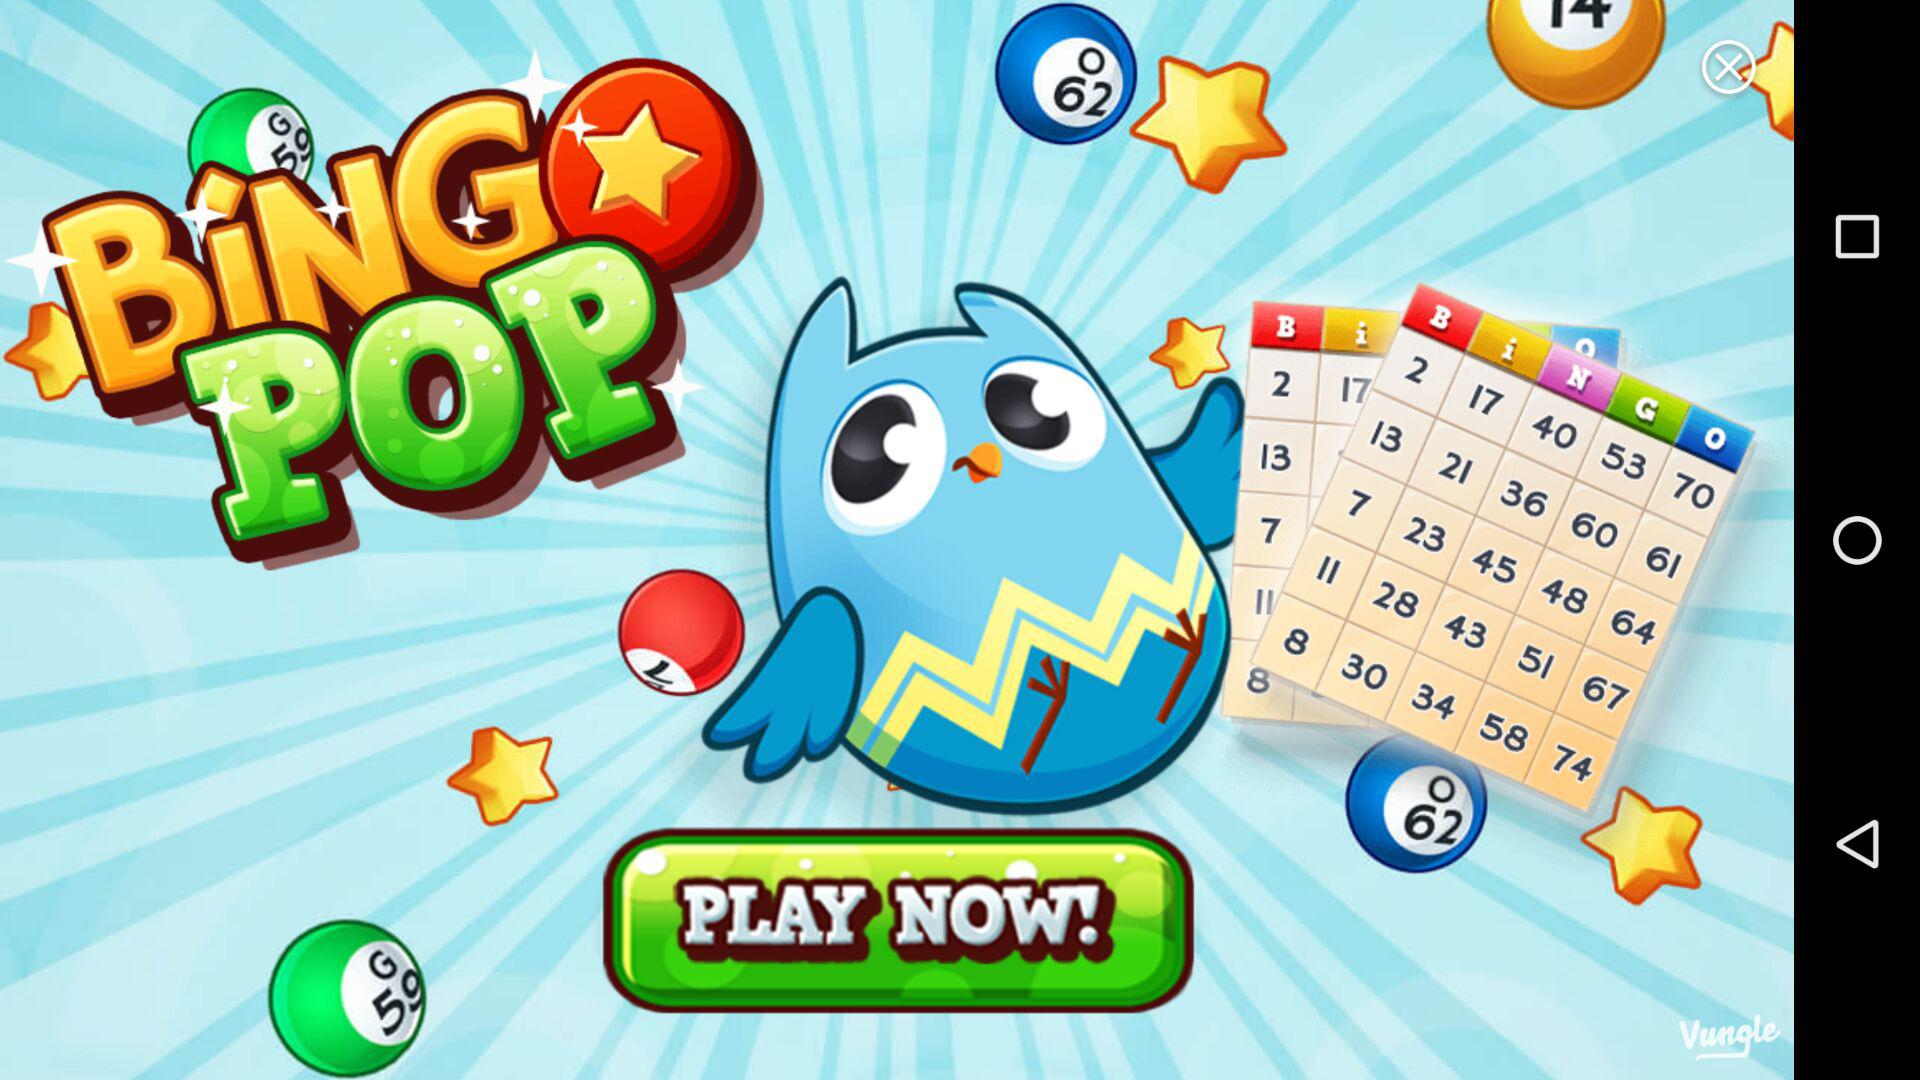What is the number of tickets for day one? The number of tickets for day one is 5. 